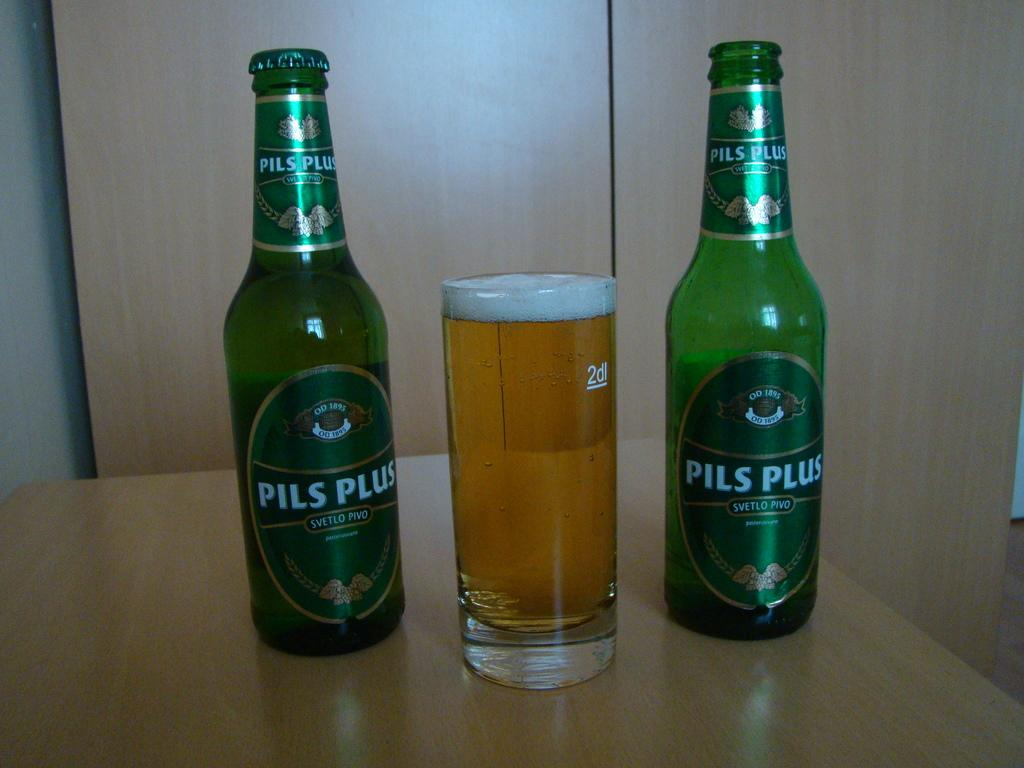<image>
Offer a succinct explanation of the picture presented. Two Pils Plus bottles, one is opened, and a glass of beer in the middle. 